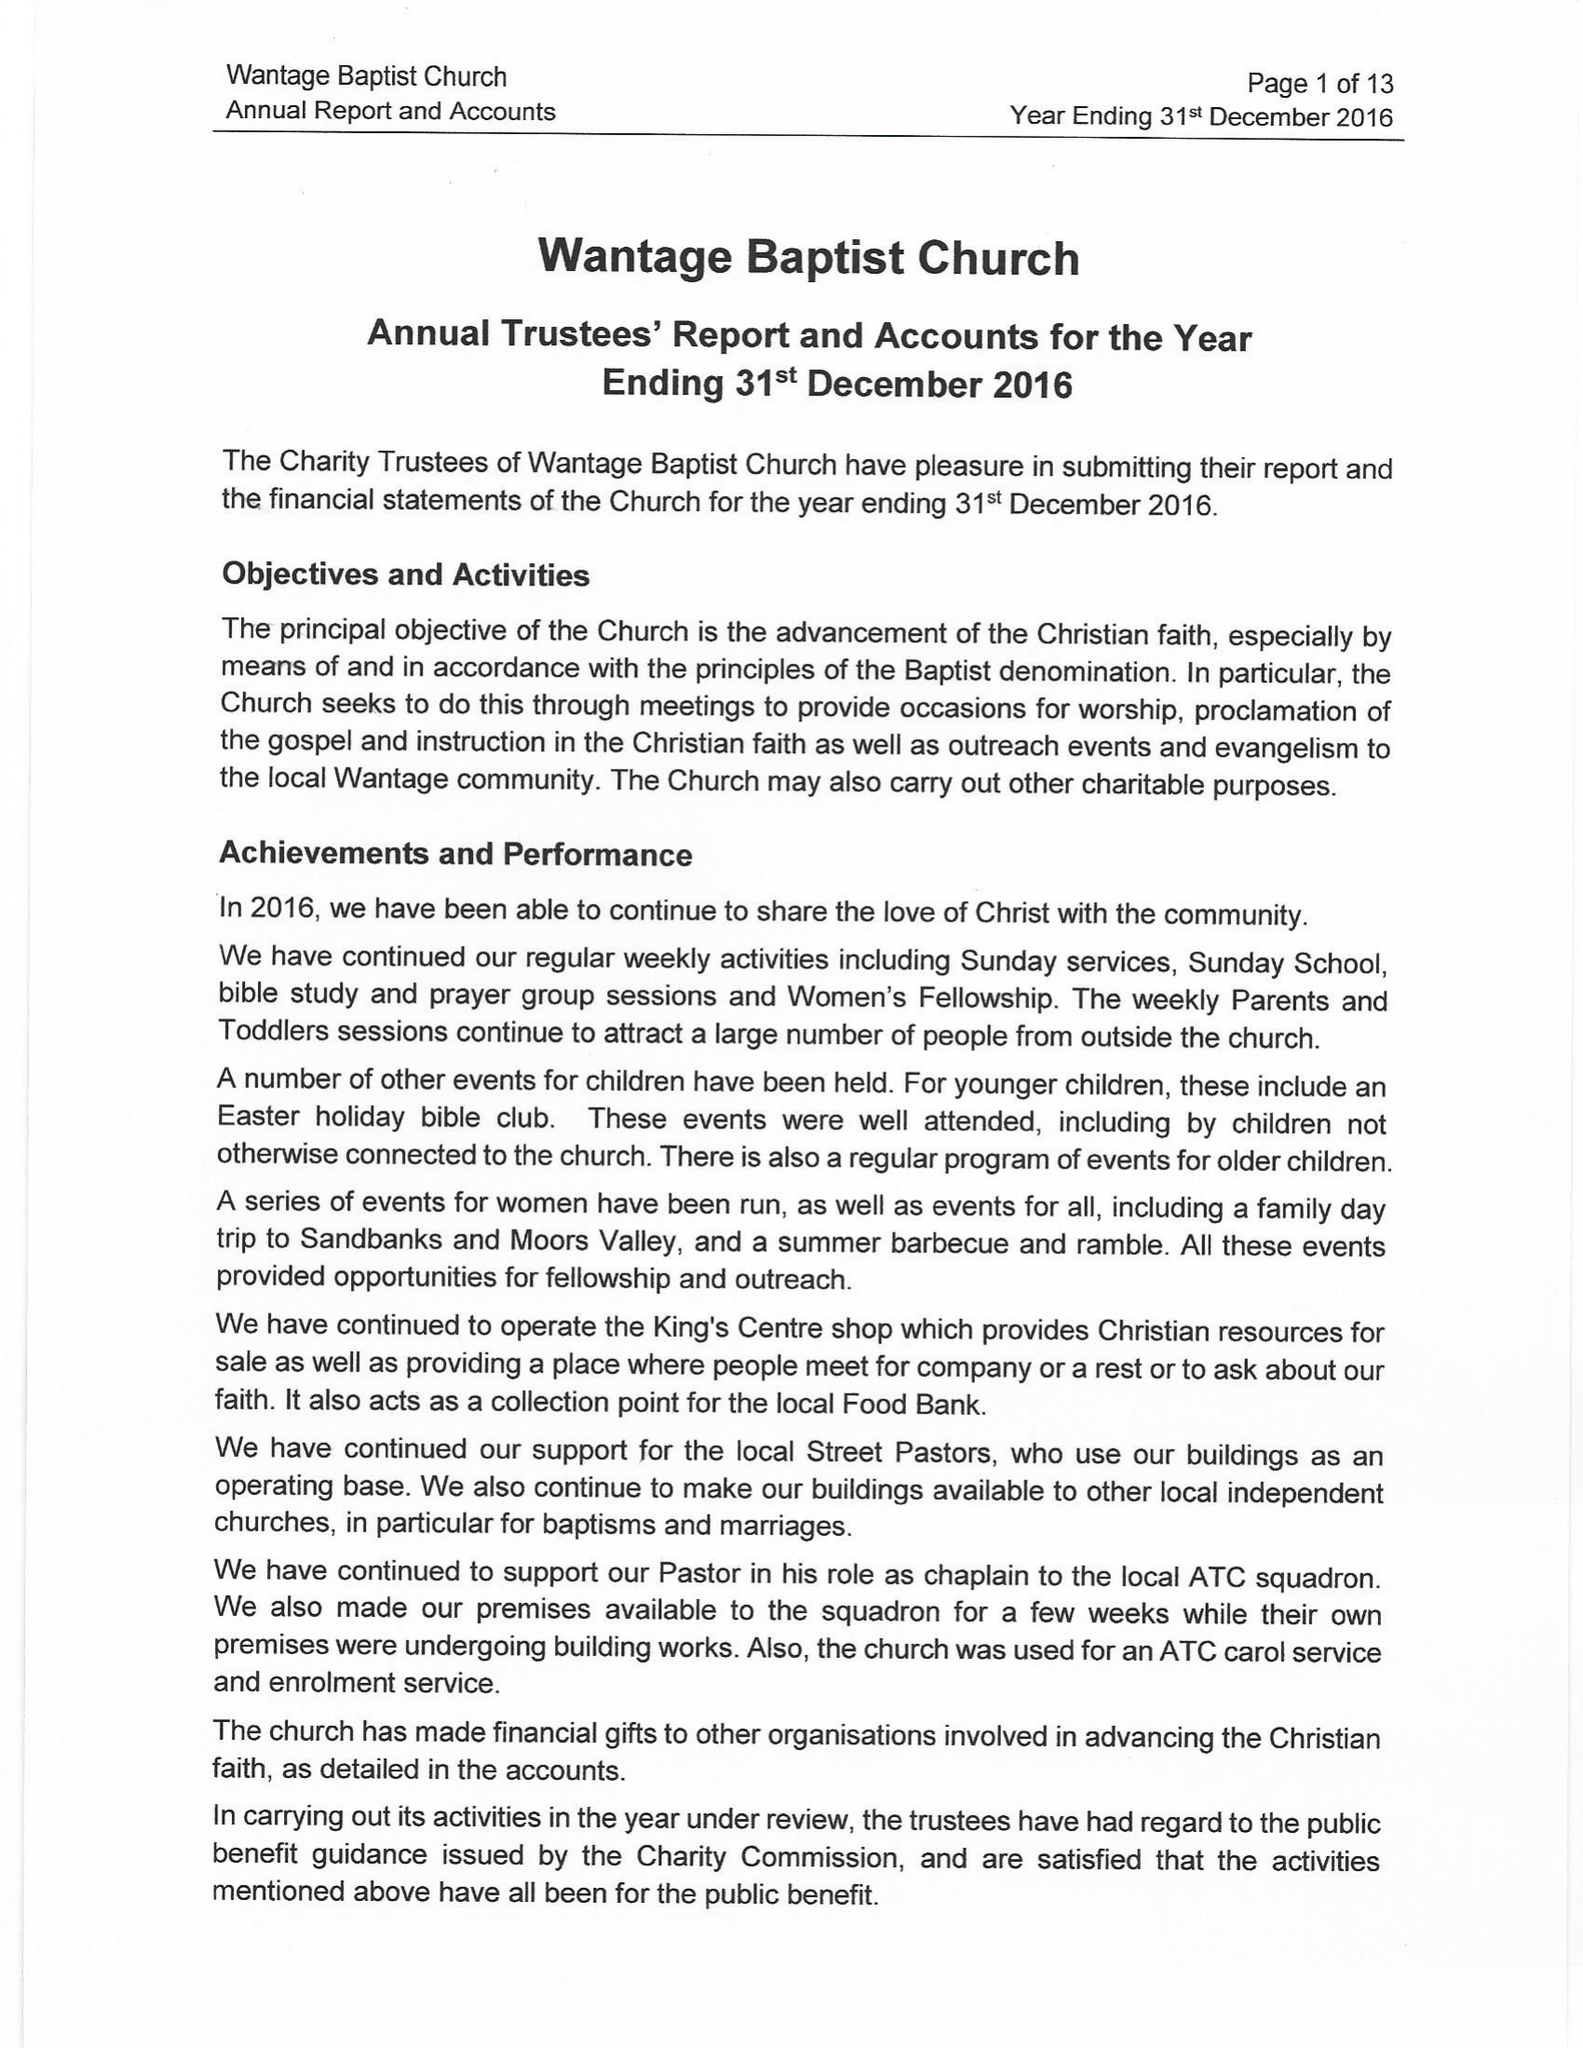What is the value for the report_date?
Answer the question using a single word or phrase. 2016-12-31 